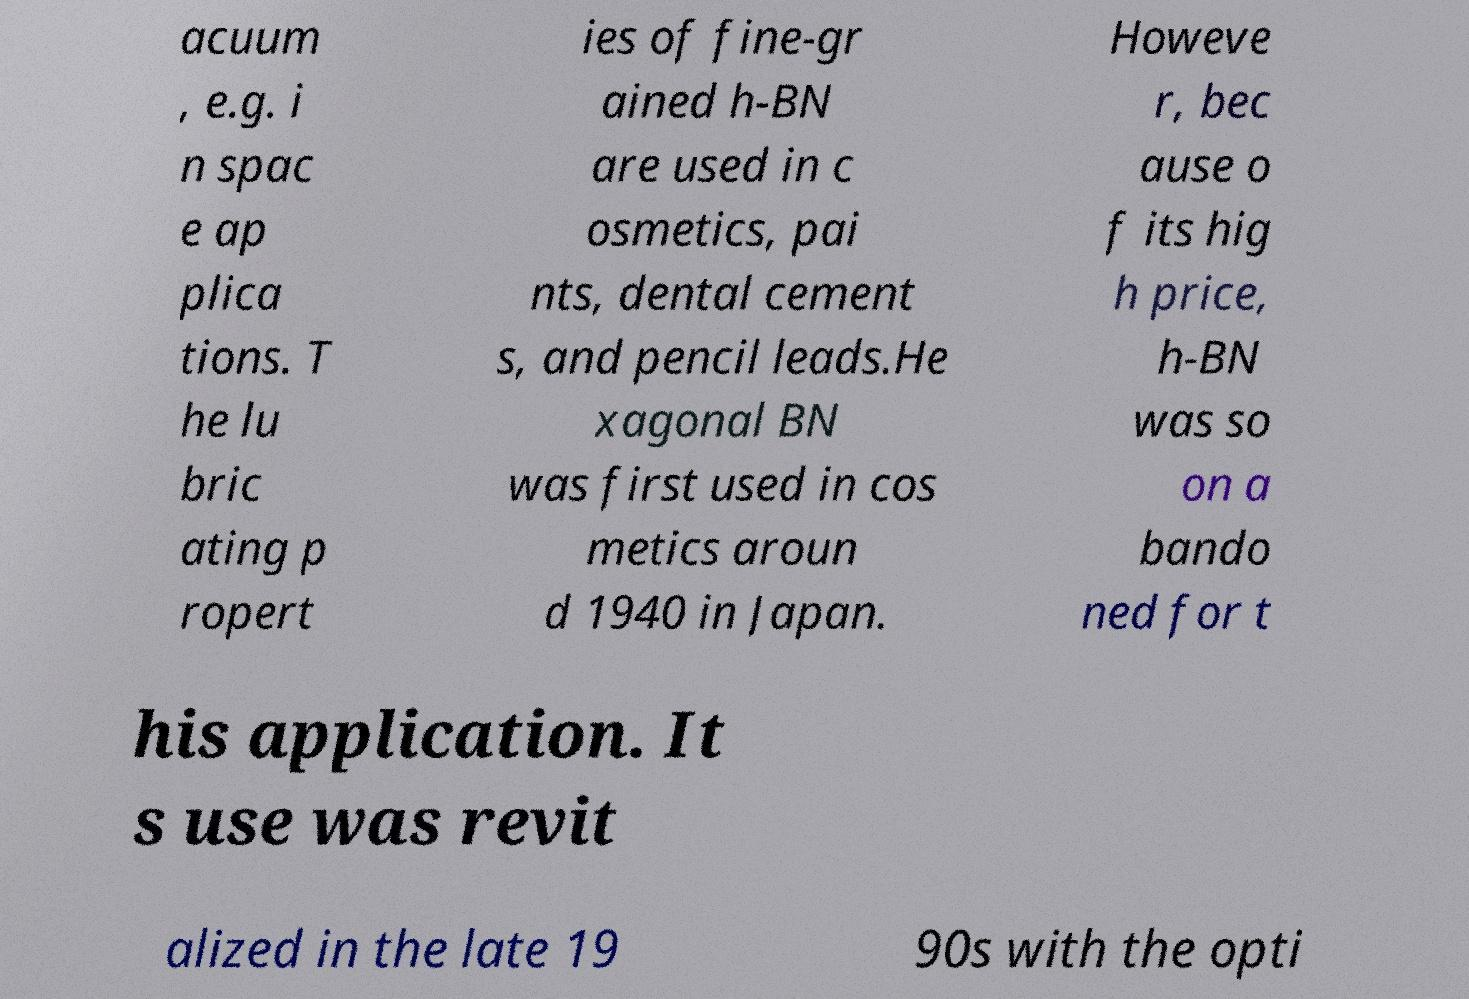For documentation purposes, I need the text within this image transcribed. Could you provide that? acuum , e.g. i n spac e ap plica tions. T he lu bric ating p ropert ies of fine-gr ained h-BN are used in c osmetics, pai nts, dental cement s, and pencil leads.He xagonal BN was first used in cos metics aroun d 1940 in Japan. Howeve r, bec ause o f its hig h price, h-BN was so on a bando ned for t his application. It s use was revit alized in the late 19 90s with the opti 